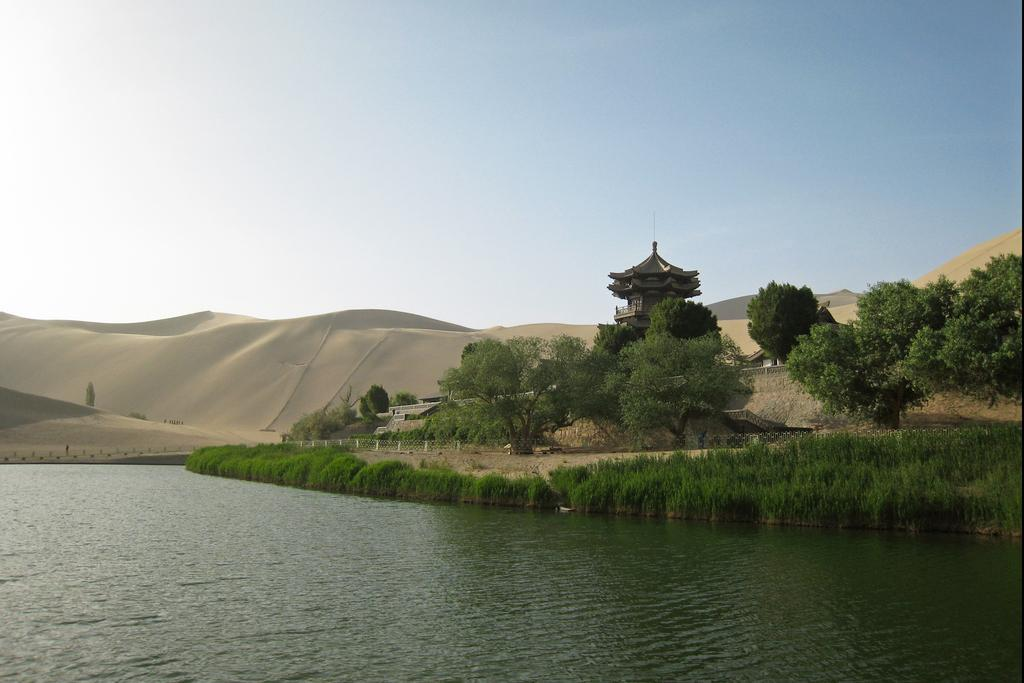What natural element can be seen in the image? Water is visible in the image. What type of vegetation is present in the image? There is grass and plants in the image. What can be seen in the background of the image? There are trees, a pagoda, and sand mountains in the background of the image. What is the condition of the sky in the image? The sky is clear and visible at the top of the image. Where is the bomb located in the image? There is no bomb present in the image. What type of room can be seen in the background of the image? There is no room visible in the image; it features an outdoor scene with natural elements and a pagoda. 